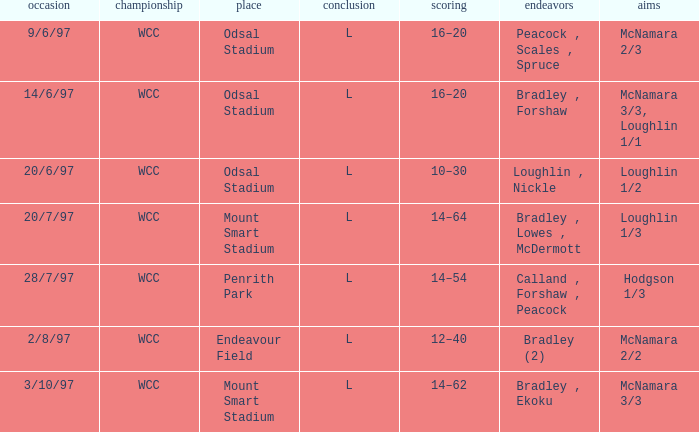What was the result on 20/6/97? 10–30. 